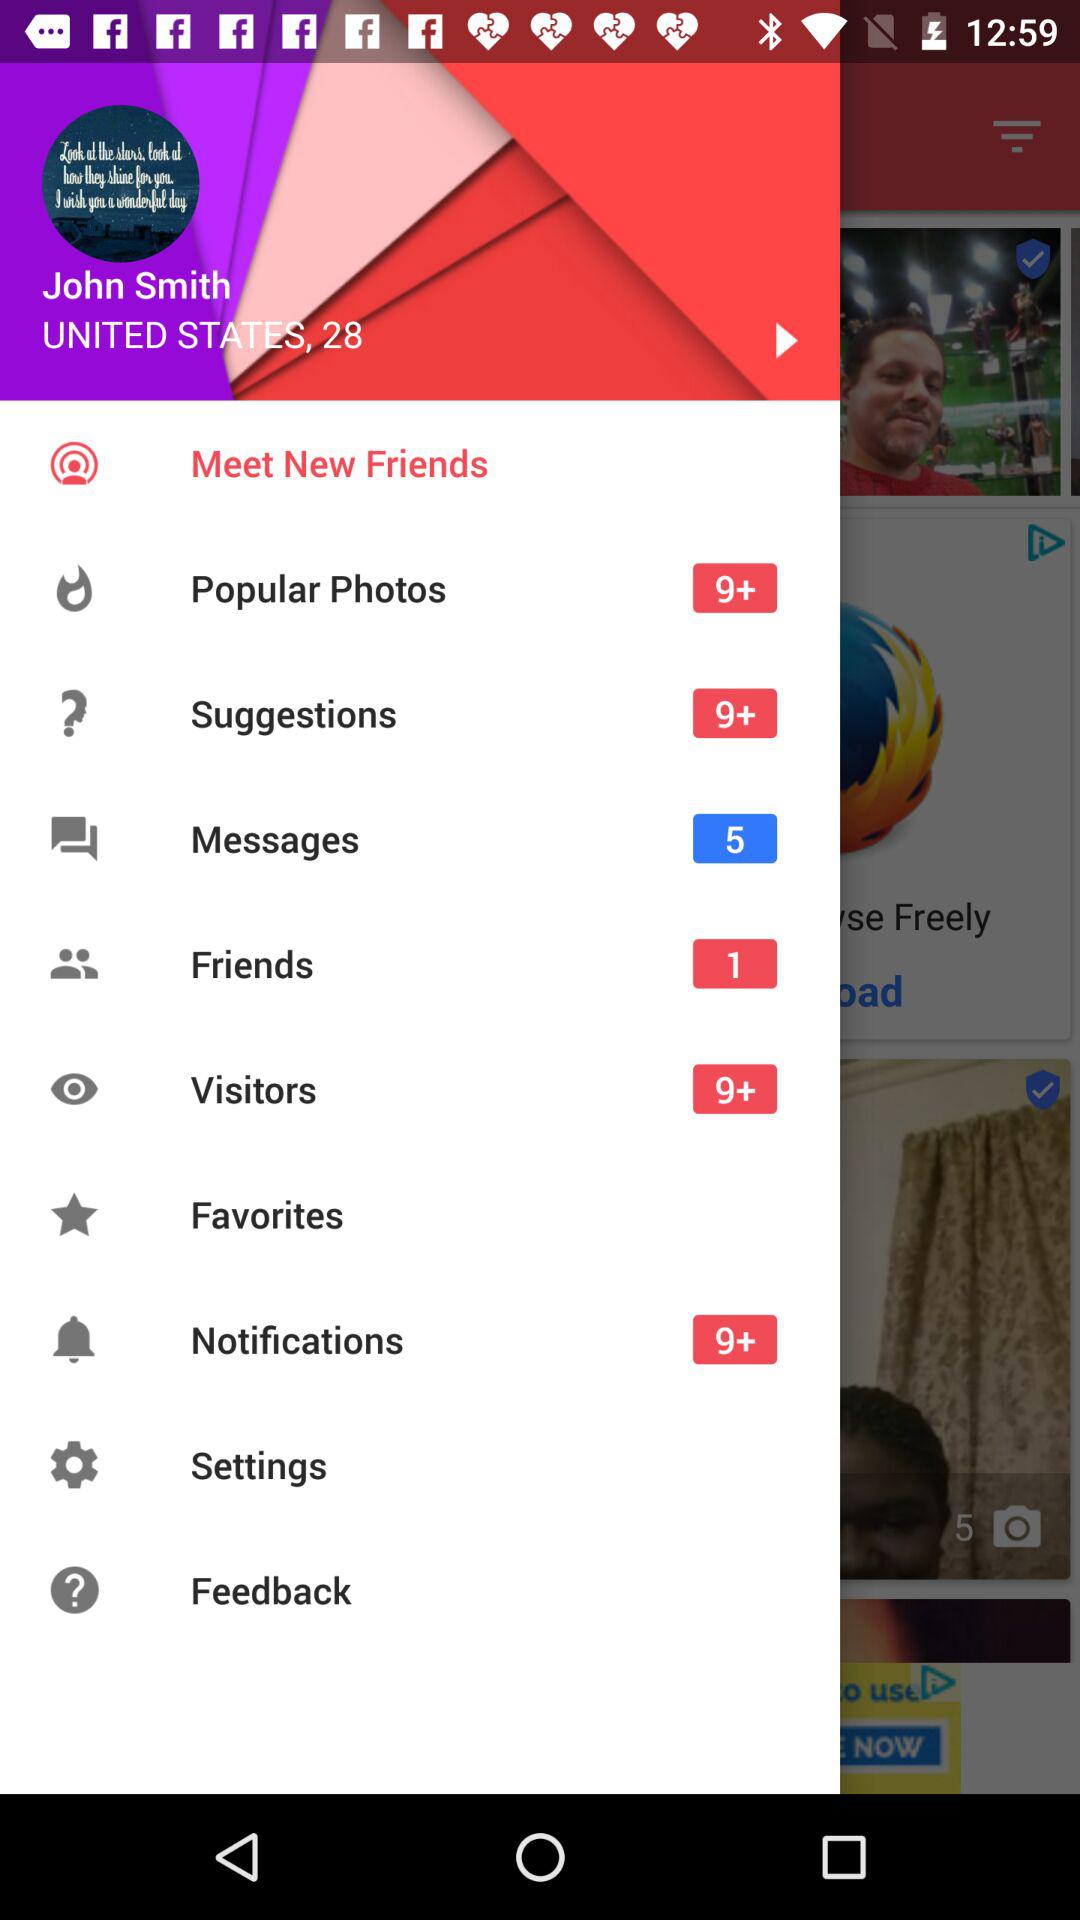How many friends are there? There is 1 friend. 